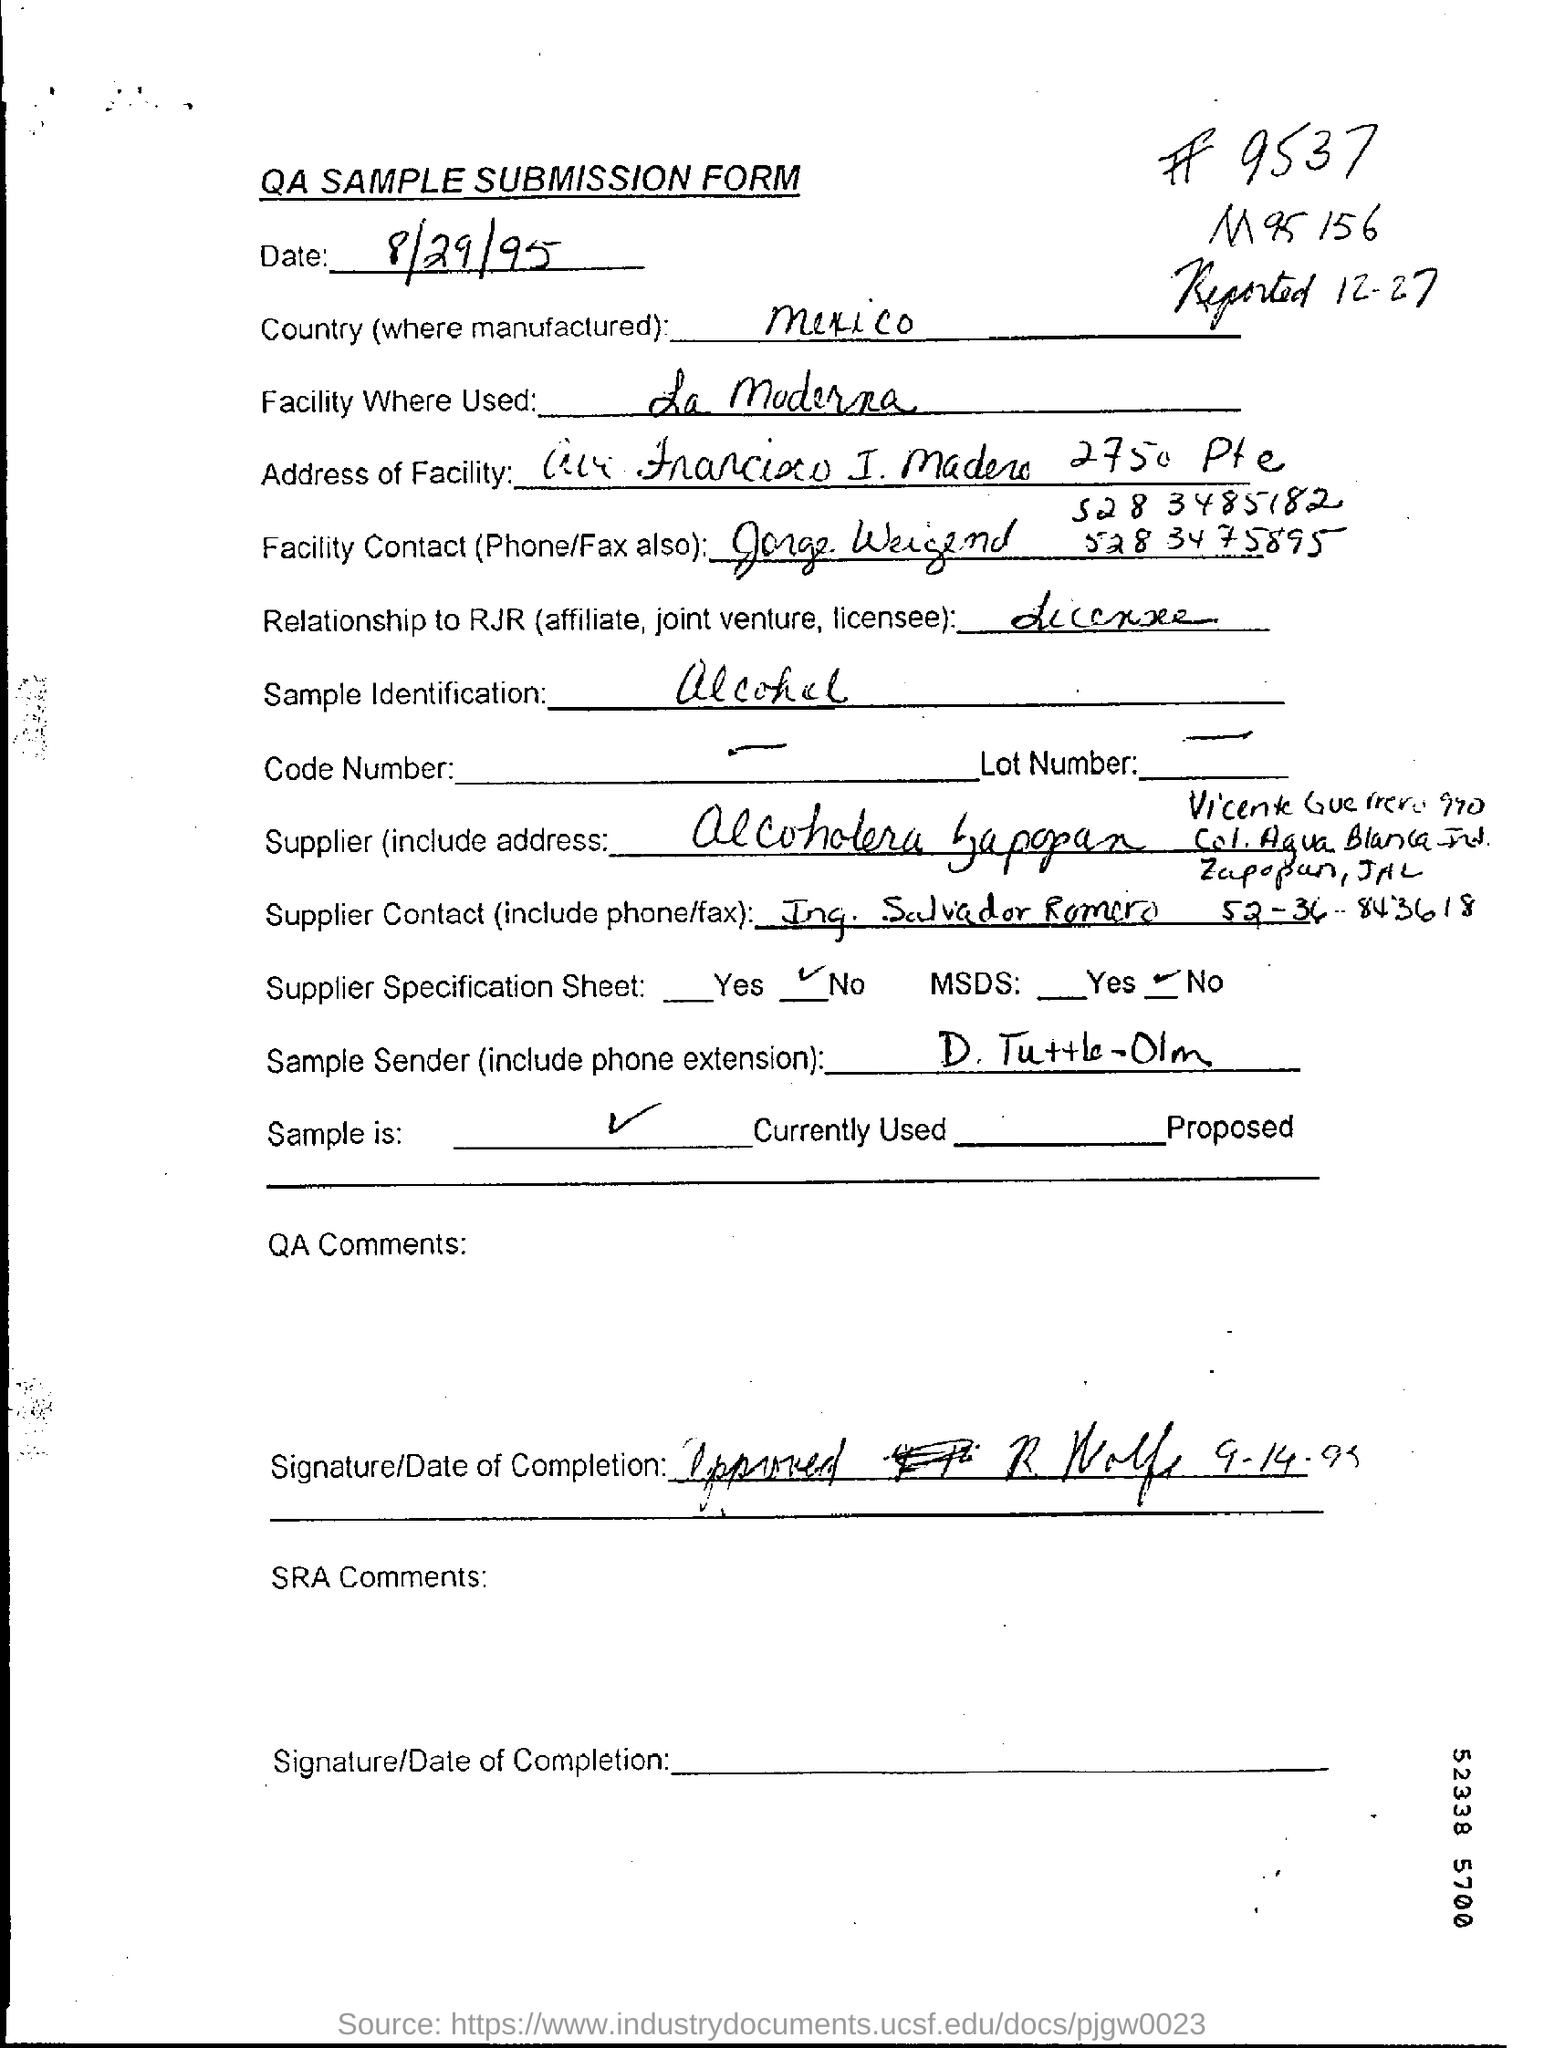Highlight a few significant elements in this photo. I have identified a sample as alcohol. The product is manufactured in Mexico. 